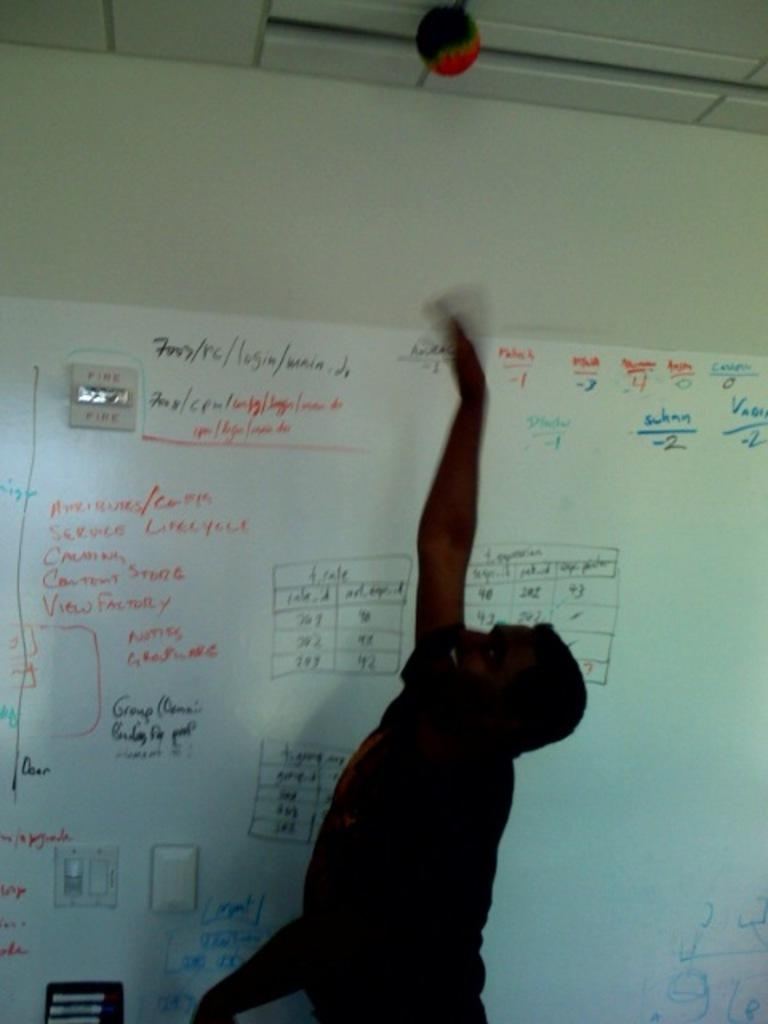<image>
Create a compact narrative representing the image presented. A white board has a strobe labelled FIRE in red next to it. 